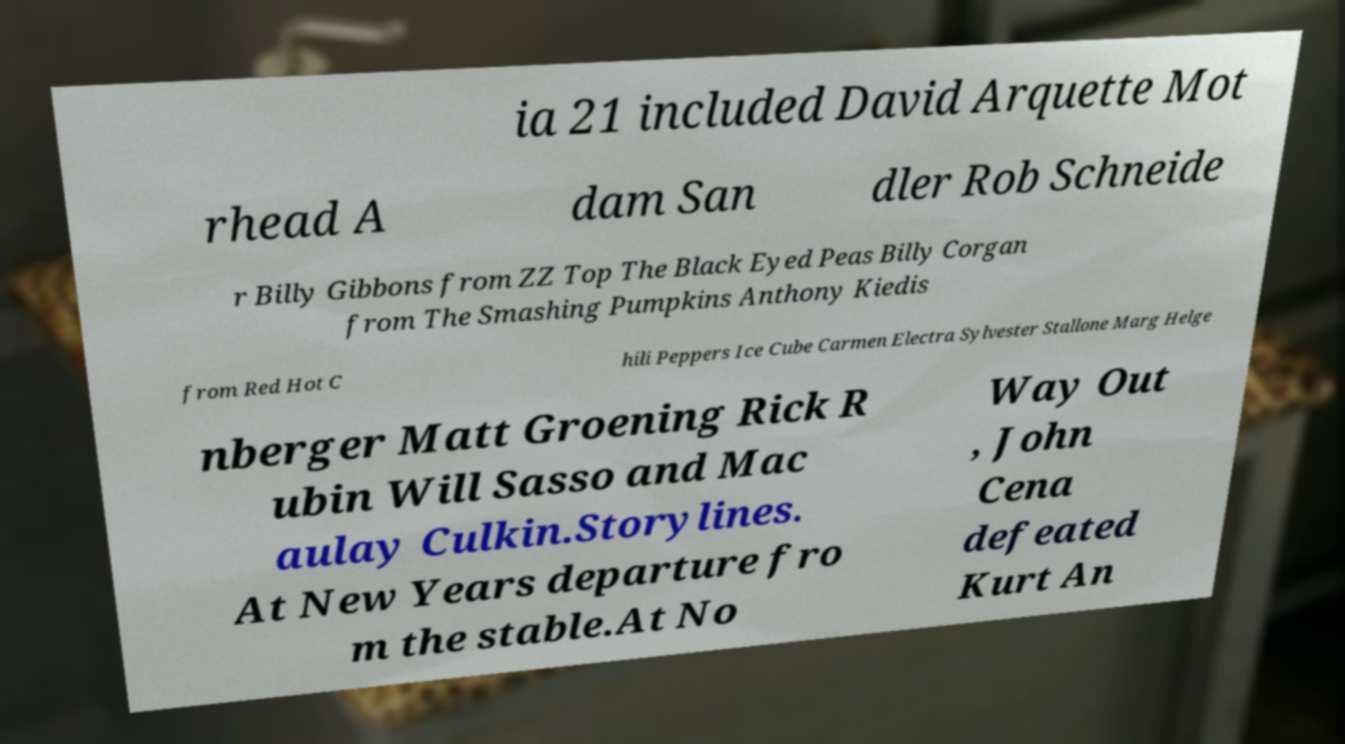Can you accurately transcribe the text from the provided image for me? ia 21 included David Arquette Mot rhead A dam San dler Rob Schneide r Billy Gibbons from ZZ Top The Black Eyed Peas Billy Corgan from The Smashing Pumpkins Anthony Kiedis from Red Hot C hili Peppers Ice Cube Carmen Electra Sylvester Stallone Marg Helge nberger Matt Groening Rick R ubin Will Sasso and Mac aulay Culkin.Storylines. At New Years departure fro m the stable.At No Way Out , John Cena defeated Kurt An 